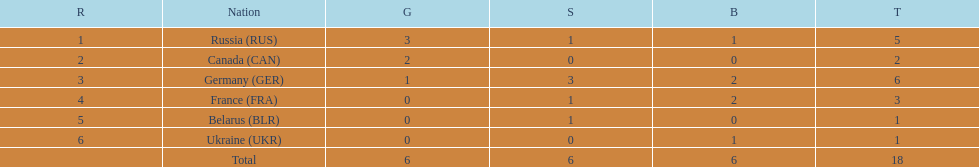Can you give me this table as a dict? {'header': ['R', 'Nation', 'G', 'S', 'B', 'T'], 'rows': [['1', 'Russia\xa0(RUS)', '3', '1', '1', '5'], ['2', 'Canada\xa0(CAN)', '2', '0', '0', '2'], ['3', 'Germany\xa0(GER)', '1', '3', '2', '6'], ['4', 'France\xa0(FRA)', '0', '1', '2', '3'], ['5', 'Belarus\xa0(BLR)', '0', '1', '0', '1'], ['6', 'Ukraine\xa0(UKR)', '0', '0', '1', '1'], ['', 'Total', '6', '6', '6', '18']]} Name the country that had the same number of bronze medals as russia. Ukraine. 